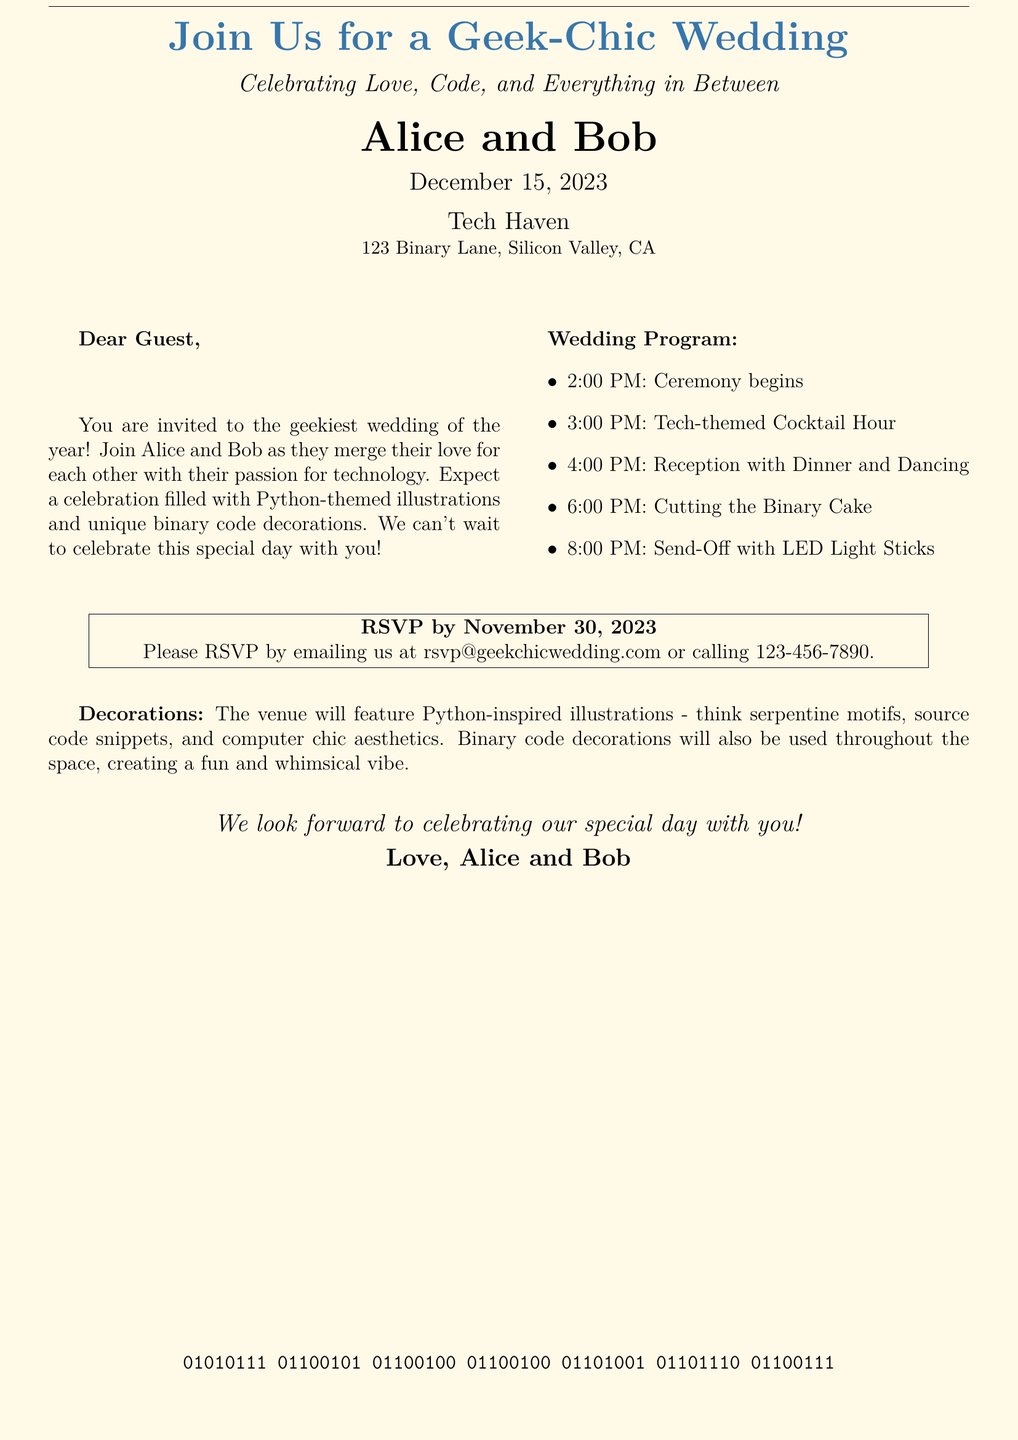What are the names of the couple? The document mentions the names of the couple getting married, which are Alice and Bob.
Answer: Alice and Bob What date is the wedding? The invitation specifies the date of the wedding, which is mentioned as December 15, 2023.
Answer: December 15, 2023 What is the address of the venue? The venue's address is provided in the document, which is 123 Binary Lane, Silicon Valley, CA.
Answer: 123 Binary Lane, Silicon Valley, CA What time does the ceremony begin? The document lists the time the ceremony starts as indicated in the wedding program section.
Answer: 2:00 PM What email should guests use to RSVP? The RSVP instructions include an email address specifically for responses, which is rsvp@geekchicwedding.com.
Answer: rsvp@geekchicwedding.com What theme is mentioned for the decorations? The decorations are described in terms of their design, specifically mentioning the Python-inspired illustrations.
Answer: Python-inspired illustrations How will guests be sent off? The send-off event is elaborated in the wedding program, indicating the use of LED light sticks for this occasion.
Answer: LED light sticks What type of cake will be cut at the wedding? The wedding program outlines the event where the cake will be cut, specifying it as the binary cake.
Answer: Binary cake 